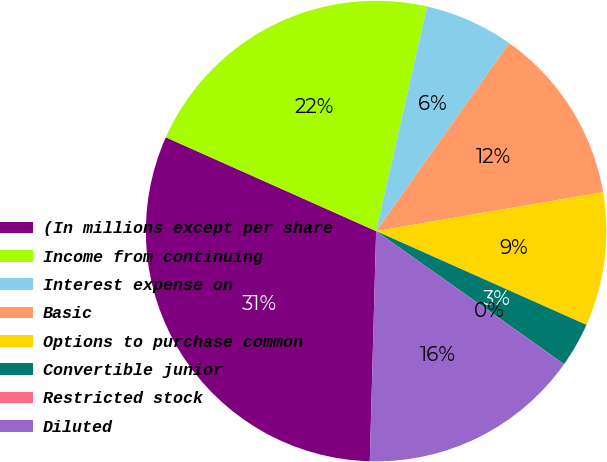<chart> <loc_0><loc_0><loc_500><loc_500><pie_chart><fcel>(In millions except per share<fcel>Income from continuing<fcel>Interest expense on<fcel>Basic<fcel>Options to purchase common<fcel>Convertible junior<fcel>Restricted stock<fcel>Diluted<nl><fcel>31.24%<fcel>21.87%<fcel>6.25%<fcel>12.5%<fcel>9.38%<fcel>3.13%<fcel>0.01%<fcel>15.62%<nl></chart> 